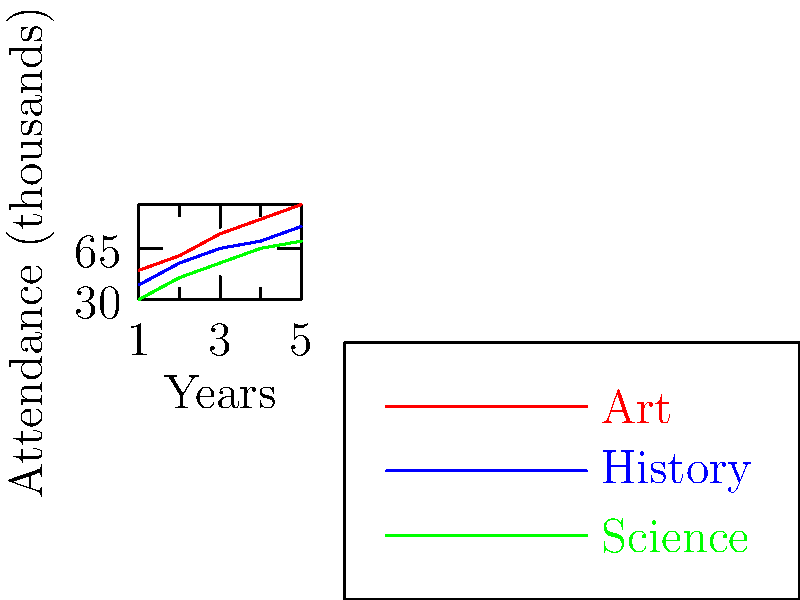Based on the attendance trends shown in the graph for different museum exhibition types over five years, which type of exhibition is likely to have the highest attendance in the upcoming year, assuming the trends continue? To answer this question, we need to analyze the trends for each exhibition type:

1. Art exhibitions (red line):
   Year 1: 50,000
   Year 5: 95,000
   Growth rate: $(95,000 - 50,000) / 50,000 = 90\%$ over 4 years

2. History exhibitions (blue line):
   Year 1: 40,000
   Year 5: 80,000
   Growth rate: $(80,000 - 40,000) / 40,000 = 100\%$ over 4 years

3. Science exhibitions (green line):
   Year 1: 30,000
   Year 5: 70,000
   Growth rate: $(70,000 - 30,000) / 30,000 = 133.33\%$ over 4 years

Although Science exhibitions show the highest growth rate, Art exhibitions have consistently higher attendance numbers throughout the five-year period. The gap between Art and the other types is also widening.

Calculating the year-over-year growth rate for Art exhibitions:
$((95,000 - 85,000) / 85,000) * 100 = 11.76\%$

Projecting this growth rate to the next year:
$95,000 * (1 + 0.1176) = 106,172$

This projection is significantly higher than the current attendance for other exhibition types, and given the consistent upward trend, it's likely to remain the highest in the upcoming year.
Answer: Art exhibitions 